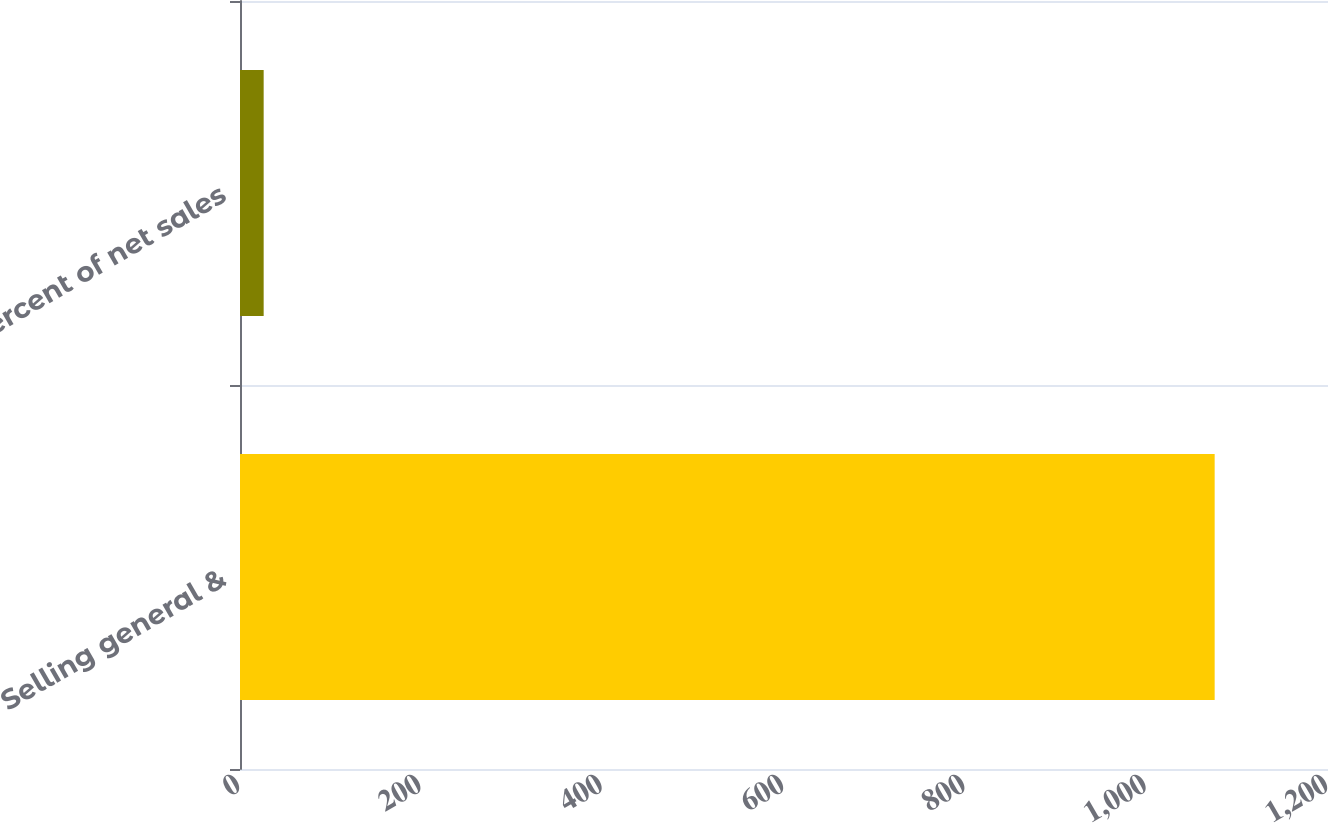Convert chart. <chart><loc_0><loc_0><loc_500><loc_500><bar_chart><fcel>Selling general &<fcel>Percent of net sales<nl><fcel>1075<fcel>26.1<nl></chart> 